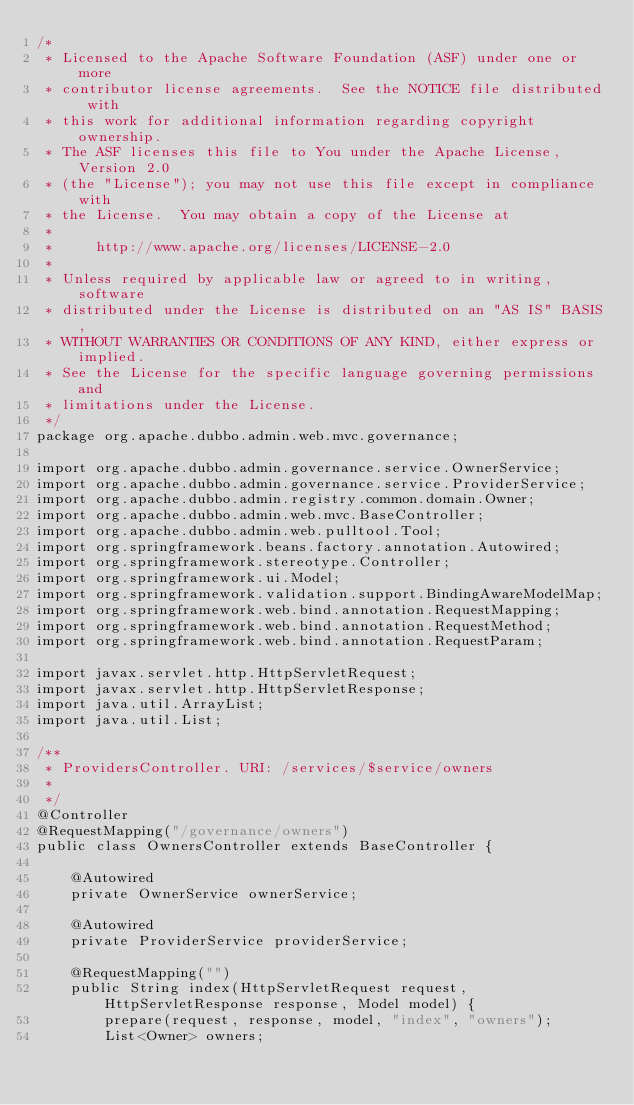Convert code to text. <code><loc_0><loc_0><loc_500><loc_500><_Java_>/*
 * Licensed to the Apache Software Foundation (ASF) under one or more
 * contributor license agreements.  See the NOTICE file distributed with
 * this work for additional information regarding copyright ownership.
 * The ASF licenses this file to You under the Apache License, Version 2.0
 * (the "License"); you may not use this file except in compliance with
 * the License.  You may obtain a copy of the License at
 *
 *     http://www.apache.org/licenses/LICENSE-2.0
 *
 * Unless required by applicable law or agreed to in writing, software
 * distributed under the License is distributed on an "AS IS" BASIS,
 * WITHOUT WARRANTIES OR CONDITIONS OF ANY KIND, either express or implied.
 * See the License for the specific language governing permissions and
 * limitations under the License.
 */
package org.apache.dubbo.admin.web.mvc.governance;

import org.apache.dubbo.admin.governance.service.OwnerService;
import org.apache.dubbo.admin.governance.service.ProviderService;
import org.apache.dubbo.admin.registry.common.domain.Owner;
import org.apache.dubbo.admin.web.mvc.BaseController;
import org.apache.dubbo.admin.web.pulltool.Tool;
import org.springframework.beans.factory.annotation.Autowired;
import org.springframework.stereotype.Controller;
import org.springframework.ui.Model;
import org.springframework.validation.support.BindingAwareModelMap;
import org.springframework.web.bind.annotation.RequestMapping;
import org.springframework.web.bind.annotation.RequestMethod;
import org.springframework.web.bind.annotation.RequestParam;

import javax.servlet.http.HttpServletRequest;
import javax.servlet.http.HttpServletResponse;
import java.util.ArrayList;
import java.util.List;

/**
 * ProvidersController. URI: /services/$service/owners
 *
 */
@Controller
@RequestMapping("/governance/owners")
public class OwnersController extends BaseController {

    @Autowired
    private OwnerService ownerService;

    @Autowired
    private ProviderService providerService;

    @RequestMapping("")
    public String index(HttpServletRequest request, HttpServletResponse response, Model model) {
        prepare(request, response, model, "index", "owners");
        List<Owner> owners;</code> 